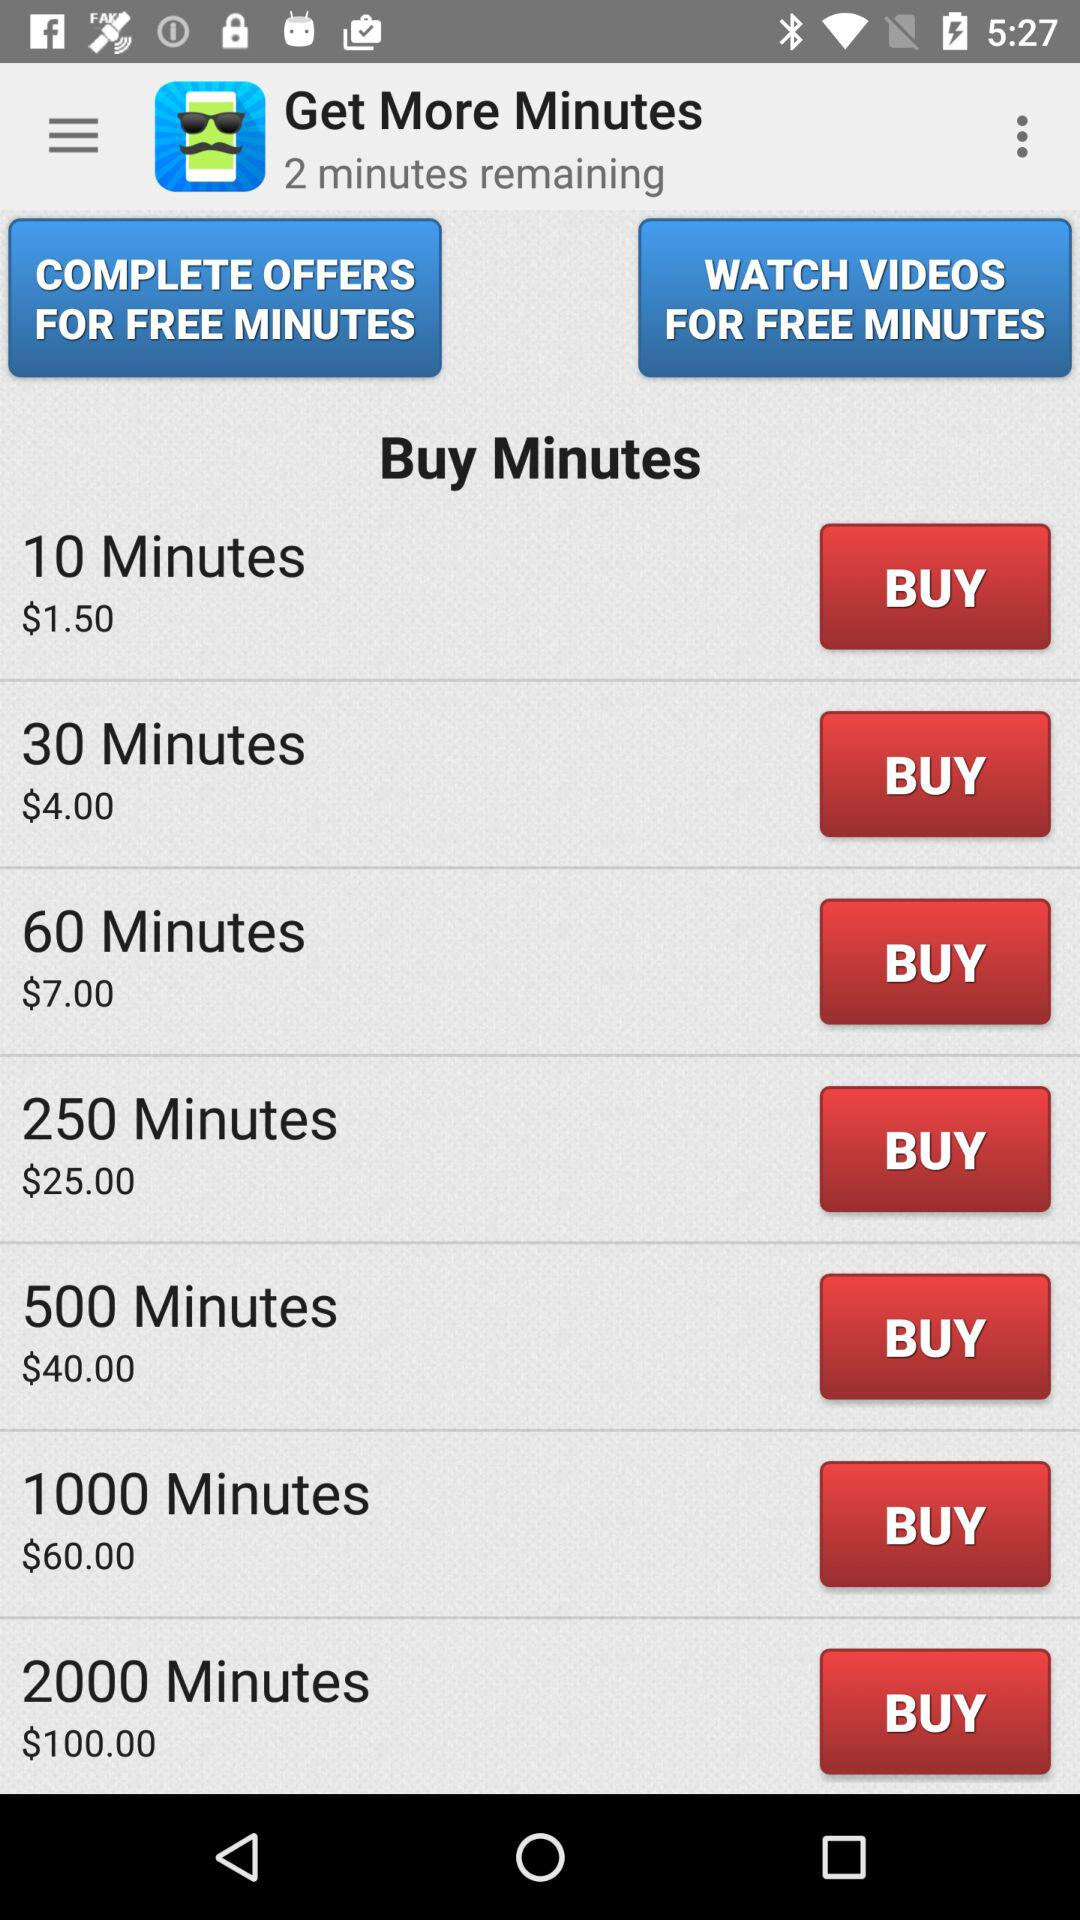How many minutes cost $25.00? The minutes that cost $25 are 250. 